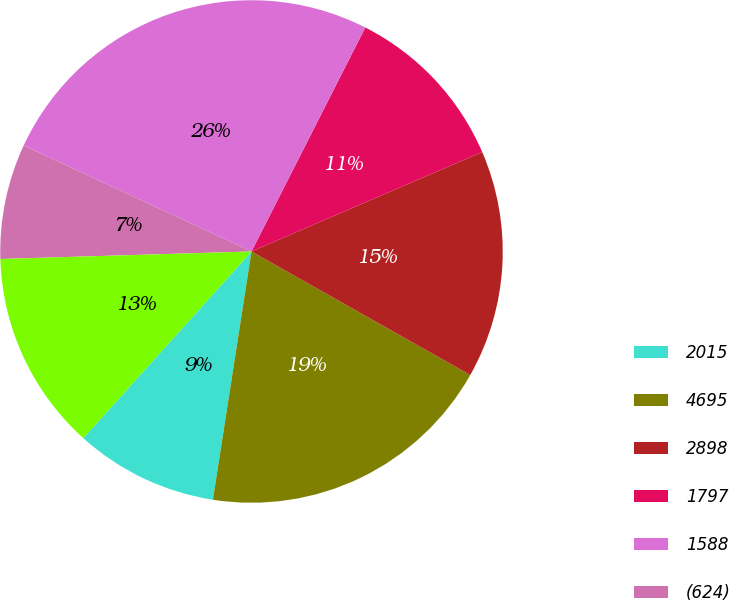Convert chart. <chart><loc_0><loc_0><loc_500><loc_500><pie_chart><fcel>2015<fcel>4695<fcel>2898<fcel>1797<fcel>1588<fcel>(624)<fcel>2761<nl><fcel>9.22%<fcel>19.27%<fcel>14.66%<fcel>11.04%<fcel>25.55%<fcel>7.41%<fcel>12.85%<nl></chart> 